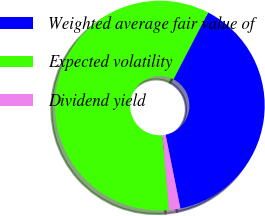Convert chart. <chart><loc_0><loc_0><loc_500><loc_500><pie_chart><fcel>Weighted average fair value of<fcel>Expected volatility<fcel>Dividend yield<nl><fcel>39.24%<fcel>59.03%<fcel>1.74%<nl></chart> 